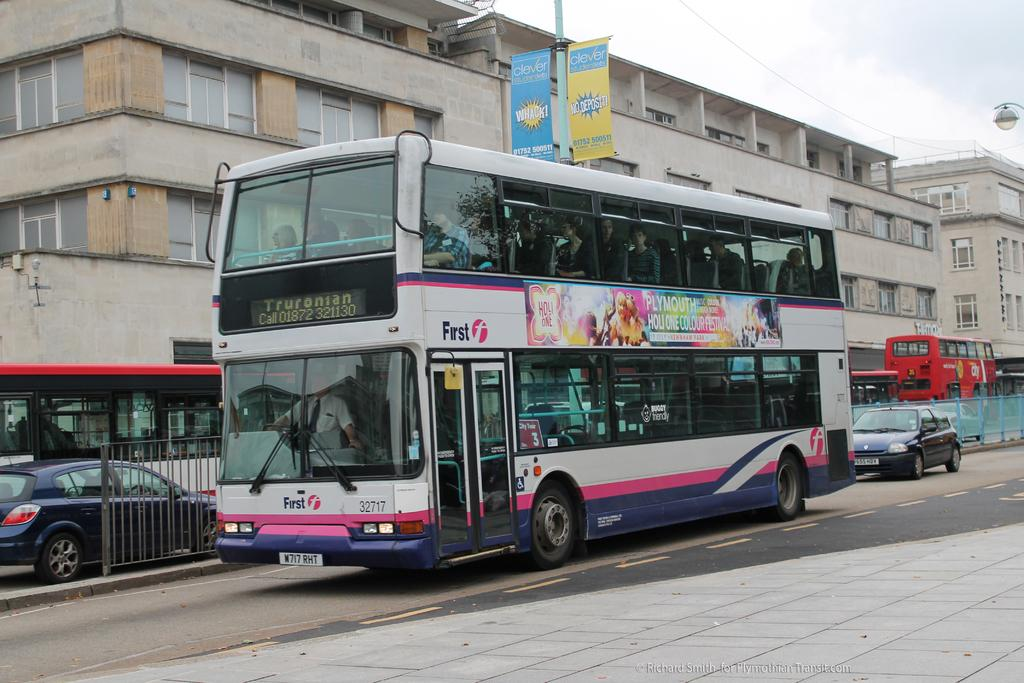<image>
Write a terse but informative summary of the picture. Truronian is displayed on the front of this public bus. 